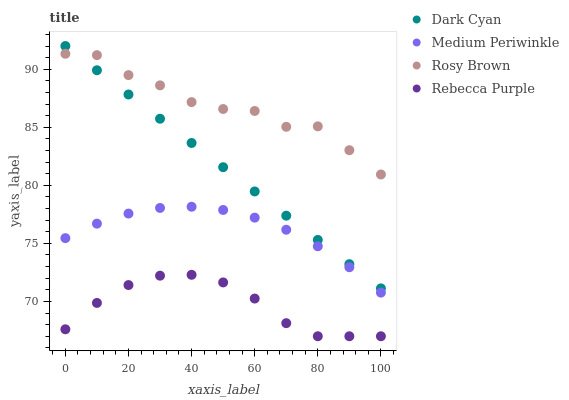Does Rebecca Purple have the minimum area under the curve?
Answer yes or no. Yes. Does Rosy Brown have the maximum area under the curve?
Answer yes or no. Yes. Does Medium Periwinkle have the minimum area under the curve?
Answer yes or no. No. Does Medium Periwinkle have the maximum area under the curve?
Answer yes or no. No. Is Dark Cyan the smoothest?
Answer yes or no. Yes. Is Rosy Brown the roughest?
Answer yes or no. Yes. Is Medium Periwinkle the smoothest?
Answer yes or no. No. Is Medium Periwinkle the roughest?
Answer yes or no. No. Does Rebecca Purple have the lowest value?
Answer yes or no. Yes. Does Medium Periwinkle have the lowest value?
Answer yes or no. No. Does Dark Cyan have the highest value?
Answer yes or no. Yes. Does Rosy Brown have the highest value?
Answer yes or no. No. Is Rebecca Purple less than Rosy Brown?
Answer yes or no. Yes. Is Dark Cyan greater than Medium Periwinkle?
Answer yes or no. Yes. Does Dark Cyan intersect Rosy Brown?
Answer yes or no. Yes. Is Dark Cyan less than Rosy Brown?
Answer yes or no. No. Is Dark Cyan greater than Rosy Brown?
Answer yes or no. No. Does Rebecca Purple intersect Rosy Brown?
Answer yes or no. No. 